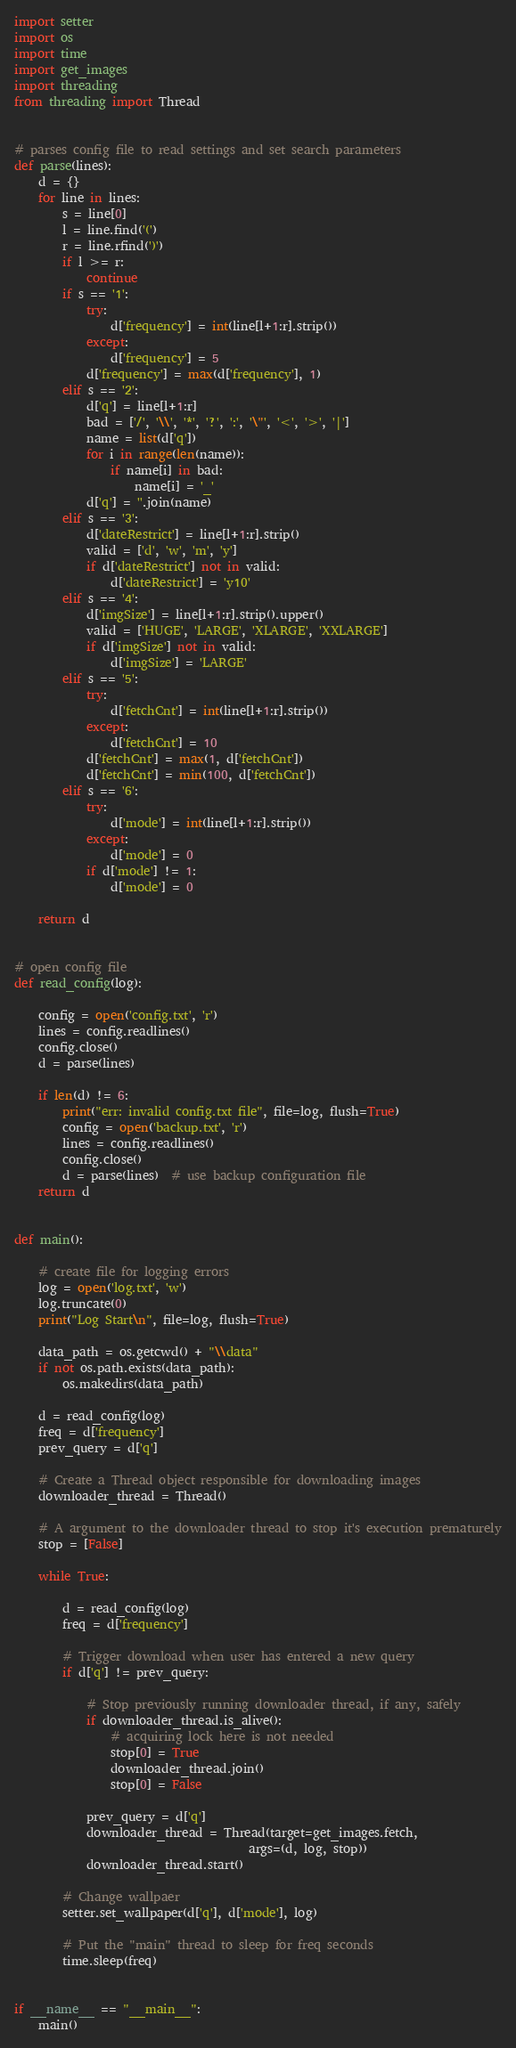Convert code to text. <code><loc_0><loc_0><loc_500><loc_500><_Python_>import setter
import os
import time
import get_images
import threading
from threading import Thread


# parses config file to read settings and set search parameters
def parse(lines):
    d = {}
    for line in lines:
        s = line[0]
        l = line.find('(')
        r = line.rfind(')')
        if l >= r:
            continue
        if s == '1':
            try:
                d['frequency'] = int(line[l+1:r].strip())
            except:
                d['frequency'] = 5
            d['frequency'] = max(d['frequency'], 1)
        elif s == '2':
            d['q'] = line[l+1:r]
            bad = ['/', '\\', '*', '?', ':', '\"', '<', '>', '|']
            name = list(d['q'])
            for i in range(len(name)):
                if name[i] in bad:
                    name[i] = '_'
            d['q'] = ''.join(name)
        elif s == '3':
            d['dateRestrict'] = line[l+1:r].strip()
            valid = ['d', 'w', 'm', 'y']
            if d['dateRestrict'] not in valid:
                d['dateRestrict'] = 'y10'
        elif s == '4':
            d['imgSize'] = line[l+1:r].strip().upper()
            valid = ['HUGE', 'LARGE', 'XLARGE', 'XXLARGE']
            if d['imgSize'] not in valid:
                d['imgSize'] = 'LARGE'
        elif s == '5':
            try:
                d['fetchCnt'] = int(line[l+1:r].strip())
            except:
                d['fetchCnt'] = 10
            d['fetchCnt'] = max(1, d['fetchCnt'])
            d['fetchCnt'] = min(100, d['fetchCnt'])
        elif s == '6':
            try:
                d['mode'] = int(line[l+1:r].strip())
            except:
                d['mode'] = 0
            if d['mode'] != 1:
                d['mode'] = 0

    return d


# open config file
def read_config(log):

    config = open('config.txt', 'r')
    lines = config.readlines()
    config.close()
    d = parse(lines)

    if len(d) != 6:
        print("err: invalid config.txt file", file=log, flush=True)
        config = open('backup.txt', 'r')
        lines = config.readlines()
        config.close()
        d = parse(lines)  # use backup configuration file
    return d


def main():

    # create file for logging errors
    log = open('log.txt', 'w')
    log.truncate(0)
    print("Log Start\n", file=log, flush=True)

    data_path = os.getcwd() + "\\data"
    if not os.path.exists(data_path):
        os.makedirs(data_path)

    d = read_config(log)
    freq = d['frequency']
    prev_query = d['q']

    # Create a Thread object responsible for downloading images
    downloader_thread = Thread()

    # A argument to the downloader thread to stop it's execution prematurely
    stop = [False]

    while True:

        d = read_config(log)
        freq = d['frequency']

        # Trigger download when user has entered a new query
        if d['q'] != prev_query:

            # Stop previously running downloader thread, if any, safely
            if downloader_thread.is_alive():
                # acquiring lock here is not needed
                stop[0] = True
                downloader_thread.join()
                stop[0] = False

            prev_query = d['q']
            downloader_thread = Thread(target=get_images.fetch,
                                       args=(d, log, stop))
            downloader_thread.start()

        # Change wallpaer
        setter.set_wallpaper(d['q'], d['mode'], log)

        # Put the "main" thread to sleep for freq seconds
        time.sleep(freq)


if __name__ == "__main__":
    main()
</code> 